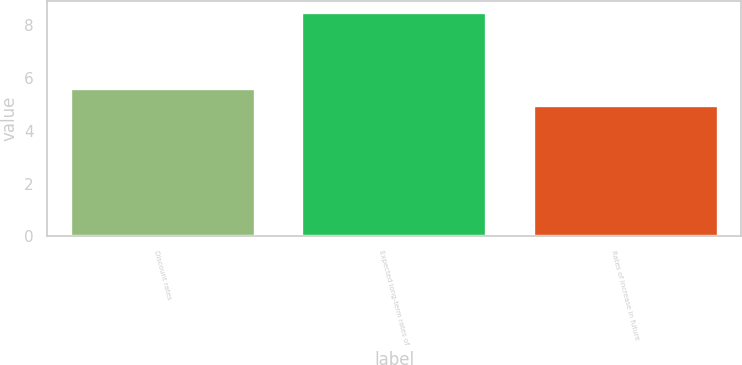Convert chart to OTSL. <chart><loc_0><loc_0><loc_500><loc_500><bar_chart><fcel>Discount rates<fcel>Expected long-term rates of<fcel>Rates of increase in future<nl><fcel>5.62<fcel>8.5<fcel>5<nl></chart> 